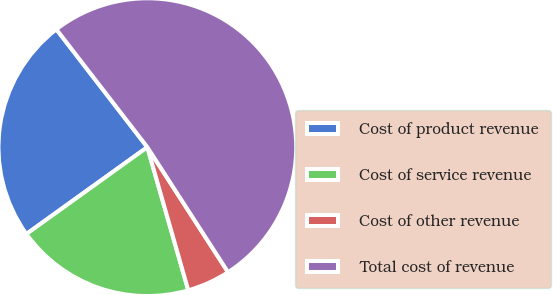Convert chart to OTSL. <chart><loc_0><loc_0><loc_500><loc_500><pie_chart><fcel>Cost of product revenue<fcel>Cost of service revenue<fcel>Cost of other revenue<fcel>Total cost of revenue<nl><fcel>24.45%<fcel>19.52%<fcel>4.69%<fcel>51.34%<nl></chart> 